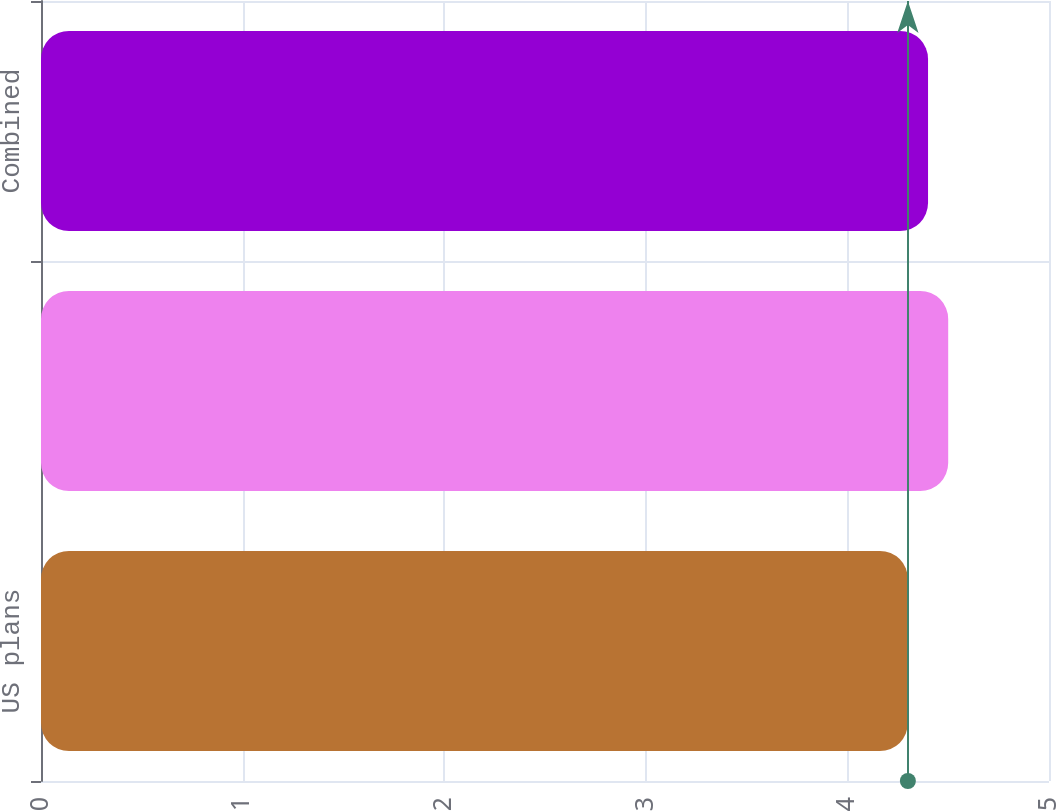Convert chart. <chart><loc_0><loc_0><loc_500><loc_500><bar_chart><fcel>US plans<fcel>International plans<fcel>Combined<nl><fcel>4.3<fcel>4.5<fcel>4.4<nl></chart> 